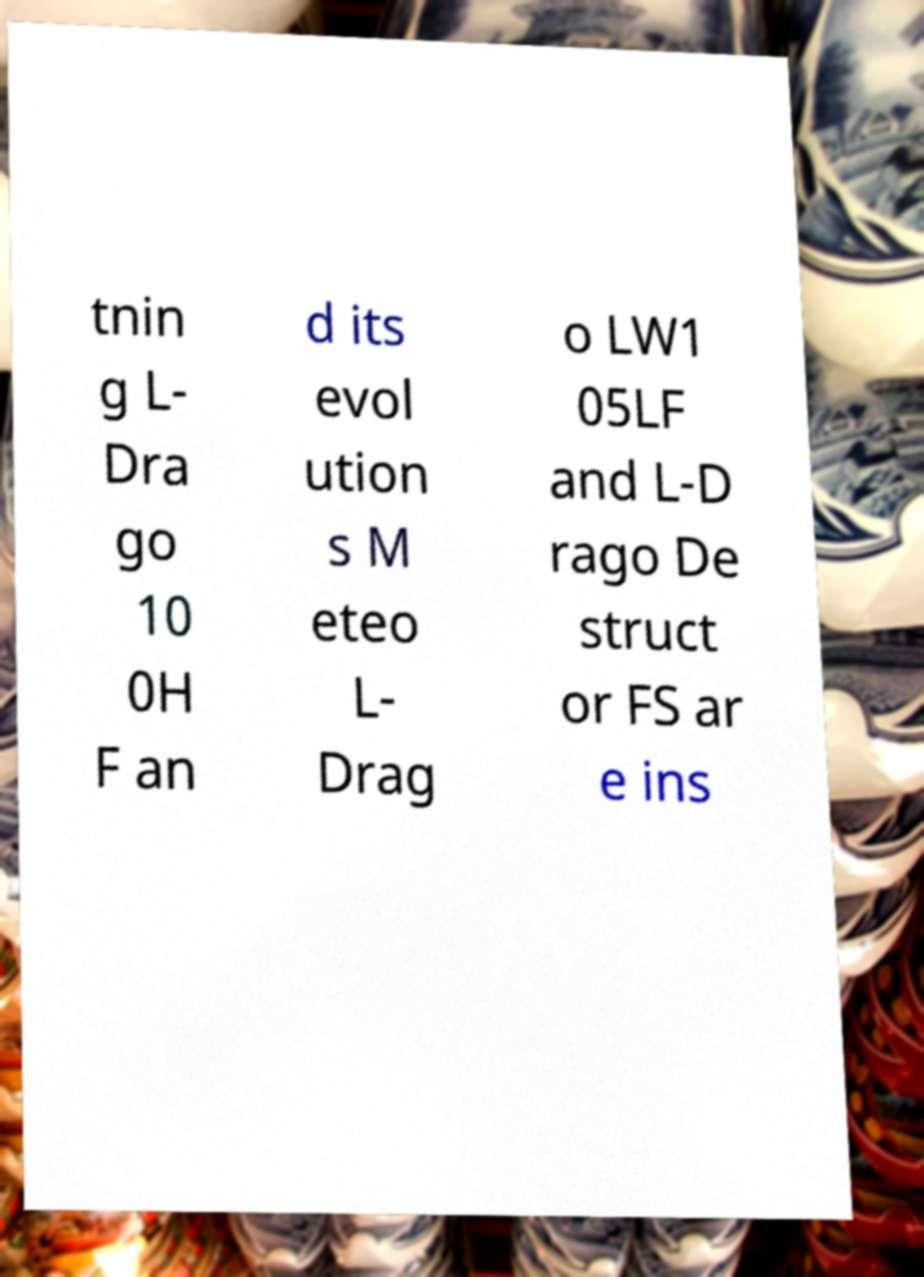What messages or text are displayed in this image? I need them in a readable, typed format. tnin g L- Dra go 10 0H F an d its evol ution s M eteo L- Drag o LW1 05LF and L-D rago De struct or FS ar e ins 